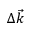Convert formula to latex. <formula><loc_0><loc_0><loc_500><loc_500>\Delta \vec { k }</formula> 